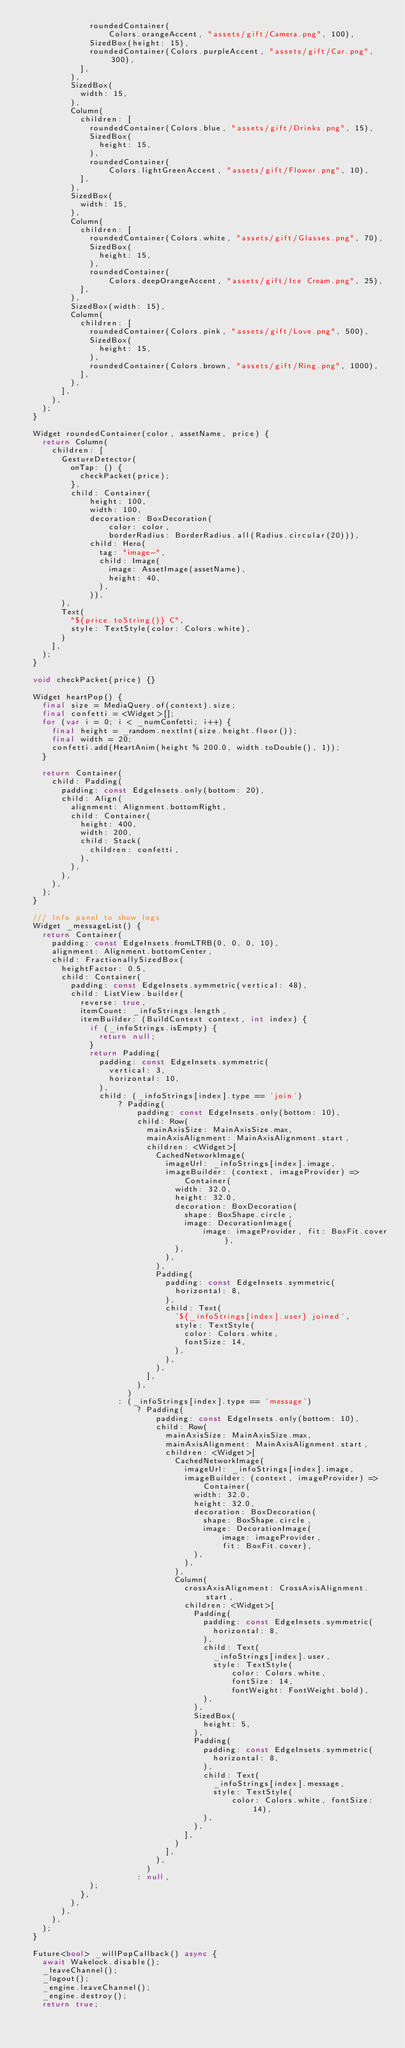<code> <loc_0><loc_0><loc_500><loc_500><_Dart_>              roundedContainer(
                  Colors.orangeAccent, "assets/gift/Camera.png", 100),
              SizedBox(height: 15),
              roundedContainer(Colors.purpleAccent, "assets/gift/Car.png", 300),
            ],
          ),
          SizedBox(
            width: 15,
          ),
          Column(
            children: [
              roundedContainer(Colors.blue, "assets/gift/Drinks.png", 15),
              SizedBox(
                height: 15,
              ),
              roundedContainer(
                  Colors.lightGreenAccent, "assets/gift/Flower.png", 10),
            ],
          ),
          SizedBox(
            width: 15,
          ),
          Column(
            children: [
              roundedContainer(Colors.white, "assets/gift/Glasses.png", 70),
              SizedBox(
                height: 15,
              ),
              roundedContainer(
                  Colors.deepOrangeAccent, "assets/gift/Ice Cream.png", 25),
            ],
          ),
          SizedBox(width: 15),
          Column(
            children: [
              roundedContainer(Colors.pink, "assets/gift/Love.png", 500),
              SizedBox(
                height: 15,
              ),
              roundedContainer(Colors.brown, "assets/gift/Ring.png", 1000),
            ],
          ),
        ],
      ),
    );
  }

  Widget roundedContainer(color, assetName, price) {
    return Column(
      children: [
        GestureDetector(
          onTap: () {
            checkPacket(price);
          },
          child: Container(
              height: 100,
              width: 100,
              decoration: BoxDecoration(
                  color: color,
                  borderRadius: BorderRadius.all(Radius.circular(20))),
              child: Hero(
                tag: "image-",
                child: Image(
                  image: AssetImage(assetName),
                  height: 40,
                ),
              )),
        ),
        Text(
          "${price.toString()} C",
          style: TextStyle(color: Colors.white),
        )
      ],
    );
  }

  void checkPacket(price) {}

  Widget heartPop() {
    final size = MediaQuery.of(context).size;
    final confetti = <Widget>[];
    for (var i = 0; i < _numConfetti; i++) {
      final height = _random.nextInt(size.height.floor());
      final width = 20;
      confetti.add(HeartAnim(height % 200.0, width.toDouble(), 1));
    }

    return Container(
      child: Padding(
        padding: const EdgeInsets.only(bottom: 20),
        child: Align(
          alignment: Alignment.bottomRight,
          child: Container(
            height: 400,
            width: 200,
            child: Stack(
              children: confetti,
            ),
          ),
        ),
      ),
    );
  }

  /// Info panel to show logs
  Widget _messageList() {
    return Container(
      padding: const EdgeInsets.fromLTRB(0, 0, 0, 10),
      alignment: Alignment.bottomCenter,
      child: FractionallySizedBox(
        heightFactor: 0.5,
        child: Container(
          padding: const EdgeInsets.symmetric(vertical: 48),
          child: ListView.builder(
            reverse: true,
            itemCount: _infoStrings.length,
            itemBuilder: (BuildContext context, int index) {
              if (_infoStrings.isEmpty) {
                return null;
              }
              return Padding(
                padding: const EdgeInsets.symmetric(
                  vertical: 3,
                  horizontal: 10,
                ),
                child: (_infoStrings[index].type == 'join')
                    ? Padding(
                        padding: const EdgeInsets.only(bottom: 10),
                        child: Row(
                          mainAxisSize: MainAxisSize.max,
                          mainAxisAlignment: MainAxisAlignment.start,
                          children: <Widget>[
                            CachedNetworkImage(
                              imageUrl: _infoStrings[index].image,
                              imageBuilder: (context, imageProvider) =>
                                  Container(
                                width: 32.0,
                                height: 32.0,
                                decoration: BoxDecoration(
                                  shape: BoxShape.circle,
                                  image: DecorationImage(
                                      image: imageProvider, fit: BoxFit.cover),
                                ),
                              ),
                            ),
                            Padding(
                              padding: const EdgeInsets.symmetric(
                                horizontal: 8,
                              ),
                              child: Text(
                                '${_infoStrings[index].user} joined',
                                style: TextStyle(
                                  color: Colors.white,
                                  fontSize: 14,
                                ),
                              ),
                            ),
                          ],
                        ),
                      )
                    : (_infoStrings[index].type == 'message')
                        ? Padding(
                            padding: const EdgeInsets.only(bottom: 10),
                            child: Row(
                              mainAxisSize: MainAxisSize.max,
                              mainAxisAlignment: MainAxisAlignment.start,
                              children: <Widget>[
                                CachedNetworkImage(
                                  imageUrl: _infoStrings[index].image,
                                  imageBuilder: (context, imageProvider) =>
                                      Container(
                                    width: 32.0,
                                    height: 32.0,
                                    decoration: BoxDecoration(
                                      shape: BoxShape.circle,
                                      image: DecorationImage(
                                          image: imageProvider,
                                          fit: BoxFit.cover),
                                    ),
                                  ),
                                ),
                                Column(
                                  crossAxisAlignment: CrossAxisAlignment.start,
                                  children: <Widget>[
                                    Padding(
                                      padding: const EdgeInsets.symmetric(
                                        horizontal: 8,
                                      ),
                                      child: Text(
                                        _infoStrings[index].user,
                                        style: TextStyle(
                                            color: Colors.white,
                                            fontSize: 14,
                                            fontWeight: FontWeight.bold),
                                      ),
                                    ),
                                    SizedBox(
                                      height: 5,
                                    ),
                                    Padding(
                                      padding: const EdgeInsets.symmetric(
                                        horizontal: 8,
                                      ),
                                      child: Text(
                                        _infoStrings[index].message,
                                        style: TextStyle(
                                            color: Colors.white, fontSize: 14),
                                      ),
                                    ),
                                  ],
                                )
                              ],
                            ),
                          )
                        : null,
              );
            },
          ),
        ),
      ),
    );
  }

  Future<bool> _willPopCallback() async {
    await Wakelock.disable();
    _leaveChannel();
    _logout();
    _engine.leaveChannel();
    _engine.destroy();
    return true;</code> 